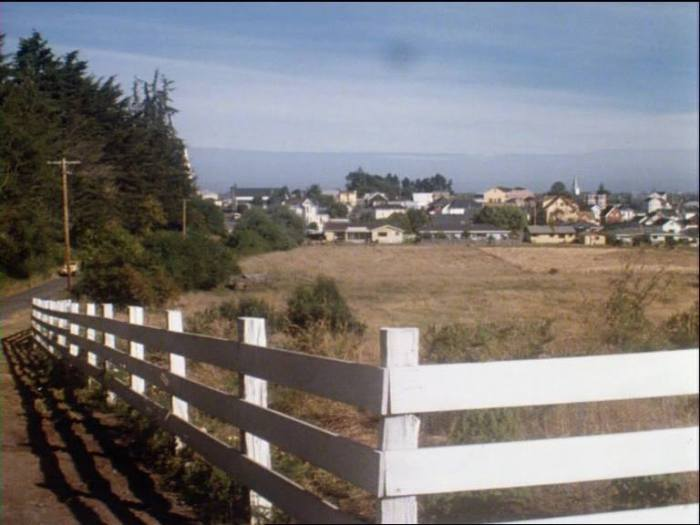Is the body of water in the background more likely to be a lake or a coastal bay, judging by the image context? Based solely on the image, the body of water in the background appears more likely to be a coastal bay rather than a lake. This inference is drawn from the broad expanse of the water visible beyond the town, suggesting that it covers a larger area than typical lakes do. Additionally, the land on the far side of the water curves outward to the left, which could indicate a coastline. Lakes are more commonly enclosed by land and would typically not have such a wide, open horizon visible from this viewpoint. Therefore, the geographical layout seen from this perspective leans towards the interpretation of a coastal bay. Furthermore, the presence of a town near this wider expanse of water might indicate human settlement patterns typical of coastal areas. 